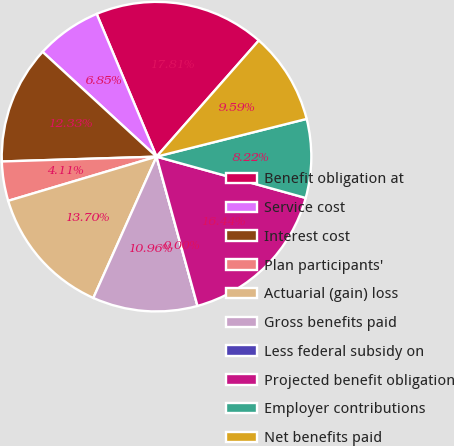Convert chart to OTSL. <chart><loc_0><loc_0><loc_500><loc_500><pie_chart><fcel>Benefit obligation at<fcel>Service cost<fcel>Interest cost<fcel>Plan participants'<fcel>Actuarial (gain) loss<fcel>Gross benefits paid<fcel>Less federal subsidy on<fcel>Projected benefit obligation<fcel>Employer contributions<fcel>Net benefits paid<nl><fcel>17.81%<fcel>6.85%<fcel>12.33%<fcel>4.11%<fcel>13.7%<fcel>10.96%<fcel>0.0%<fcel>16.44%<fcel>8.22%<fcel>9.59%<nl></chart> 